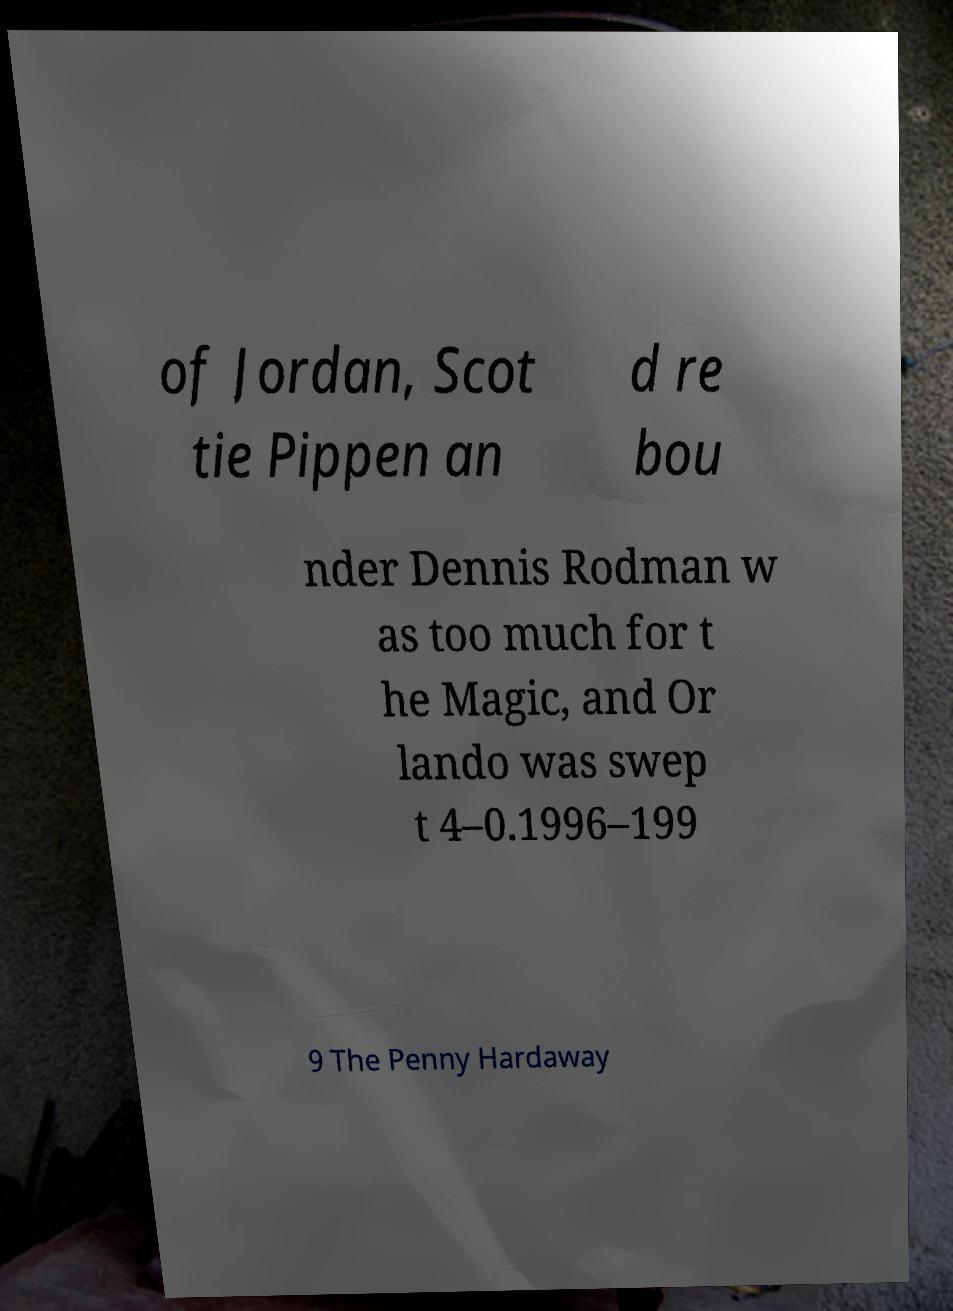Please read and relay the text visible in this image. What does it say? of Jordan, Scot tie Pippen an d re bou nder Dennis Rodman w as too much for t he Magic, and Or lando was swep t 4–0.1996–199 9 The Penny Hardaway 